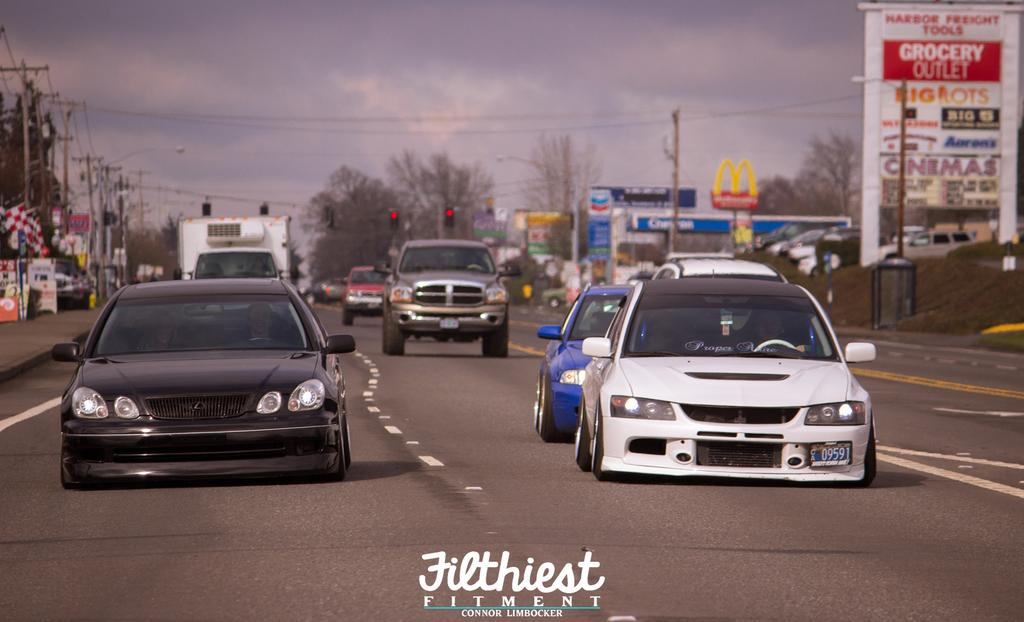Provide a one-sentence caption for the provided image. Two Japanese tuner cars on a highway by Filthiest Fitment. 